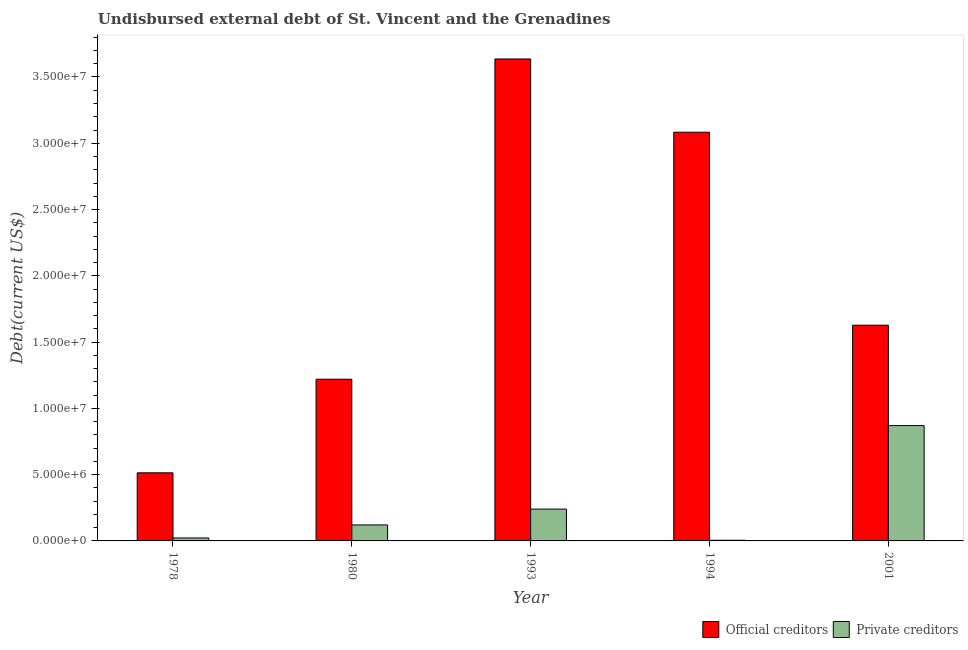How many groups of bars are there?
Keep it short and to the point. 5. How many bars are there on the 1st tick from the left?
Your answer should be compact. 2. What is the label of the 3rd group of bars from the left?
Offer a very short reply. 1993. In how many cases, is the number of bars for a given year not equal to the number of legend labels?
Ensure brevity in your answer.  0. What is the undisbursed external debt of private creditors in 1978?
Provide a succinct answer. 2.23e+05. Across all years, what is the maximum undisbursed external debt of official creditors?
Provide a succinct answer. 3.64e+07. Across all years, what is the minimum undisbursed external debt of official creditors?
Offer a very short reply. 5.14e+06. In which year was the undisbursed external debt of private creditors maximum?
Offer a very short reply. 2001. What is the total undisbursed external debt of private creditors in the graph?
Provide a succinct answer. 1.26e+07. What is the difference between the undisbursed external debt of official creditors in 1978 and that in 1993?
Offer a very short reply. -3.12e+07. What is the difference between the undisbursed external debt of official creditors in 1978 and the undisbursed external debt of private creditors in 2001?
Ensure brevity in your answer.  -1.11e+07. What is the average undisbursed external debt of official creditors per year?
Your answer should be compact. 2.02e+07. What is the ratio of the undisbursed external debt of private creditors in 1980 to that in 1993?
Provide a short and direct response. 0.5. Is the undisbursed external debt of official creditors in 1978 less than that in 1993?
Give a very brief answer. Yes. Is the difference between the undisbursed external debt of private creditors in 1993 and 2001 greater than the difference between the undisbursed external debt of official creditors in 1993 and 2001?
Ensure brevity in your answer.  No. What is the difference between the highest and the second highest undisbursed external debt of official creditors?
Offer a terse response. 5.52e+06. What is the difference between the highest and the lowest undisbursed external debt of private creditors?
Provide a succinct answer. 8.65e+06. Is the sum of the undisbursed external debt of official creditors in 1993 and 2001 greater than the maximum undisbursed external debt of private creditors across all years?
Offer a very short reply. Yes. What does the 1st bar from the left in 2001 represents?
Keep it short and to the point. Official creditors. What does the 2nd bar from the right in 1993 represents?
Provide a succinct answer. Official creditors. How many bars are there?
Offer a very short reply. 10. Are all the bars in the graph horizontal?
Make the answer very short. No. How many years are there in the graph?
Your answer should be compact. 5. Does the graph contain any zero values?
Keep it short and to the point. No. Where does the legend appear in the graph?
Provide a succinct answer. Bottom right. How many legend labels are there?
Offer a terse response. 2. What is the title of the graph?
Your answer should be very brief. Undisbursed external debt of St. Vincent and the Grenadines. Does "ODA received" appear as one of the legend labels in the graph?
Provide a short and direct response. No. What is the label or title of the X-axis?
Make the answer very short. Year. What is the label or title of the Y-axis?
Your answer should be very brief. Debt(current US$). What is the Debt(current US$) of Official creditors in 1978?
Provide a short and direct response. 5.14e+06. What is the Debt(current US$) in Private creditors in 1978?
Your response must be concise. 2.23e+05. What is the Debt(current US$) of Official creditors in 1980?
Your answer should be compact. 1.22e+07. What is the Debt(current US$) in Private creditors in 1980?
Ensure brevity in your answer.  1.21e+06. What is the Debt(current US$) in Official creditors in 1993?
Your answer should be very brief. 3.64e+07. What is the Debt(current US$) in Private creditors in 1993?
Offer a very short reply. 2.40e+06. What is the Debt(current US$) of Official creditors in 1994?
Offer a terse response. 3.08e+07. What is the Debt(current US$) in Private creditors in 1994?
Your response must be concise. 5.10e+04. What is the Debt(current US$) of Official creditors in 2001?
Your answer should be very brief. 1.63e+07. What is the Debt(current US$) in Private creditors in 2001?
Give a very brief answer. 8.70e+06. Across all years, what is the maximum Debt(current US$) in Official creditors?
Offer a very short reply. 3.64e+07. Across all years, what is the maximum Debt(current US$) of Private creditors?
Offer a very short reply. 8.70e+06. Across all years, what is the minimum Debt(current US$) in Official creditors?
Offer a very short reply. 5.14e+06. Across all years, what is the minimum Debt(current US$) of Private creditors?
Ensure brevity in your answer.  5.10e+04. What is the total Debt(current US$) of Official creditors in the graph?
Give a very brief answer. 1.01e+08. What is the total Debt(current US$) of Private creditors in the graph?
Ensure brevity in your answer.  1.26e+07. What is the difference between the Debt(current US$) of Official creditors in 1978 and that in 1980?
Ensure brevity in your answer.  -7.06e+06. What is the difference between the Debt(current US$) of Private creditors in 1978 and that in 1980?
Your answer should be compact. -9.84e+05. What is the difference between the Debt(current US$) of Official creditors in 1978 and that in 1993?
Provide a succinct answer. -3.12e+07. What is the difference between the Debt(current US$) in Private creditors in 1978 and that in 1993?
Offer a terse response. -2.18e+06. What is the difference between the Debt(current US$) of Official creditors in 1978 and that in 1994?
Your answer should be very brief. -2.57e+07. What is the difference between the Debt(current US$) in Private creditors in 1978 and that in 1994?
Keep it short and to the point. 1.72e+05. What is the difference between the Debt(current US$) of Official creditors in 1978 and that in 2001?
Give a very brief answer. -1.11e+07. What is the difference between the Debt(current US$) in Private creditors in 1978 and that in 2001?
Provide a short and direct response. -8.48e+06. What is the difference between the Debt(current US$) in Official creditors in 1980 and that in 1993?
Your response must be concise. -2.42e+07. What is the difference between the Debt(current US$) in Private creditors in 1980 and that in 1993?
Make the answer very short. -1.19e+06. What is the difference between the Debt(current US$) of Official creditors in 1980 and that in 1994?
Give a very brief answer. -1.86e+07. What is the difference between the Debt(current US$) of Private creditors in 1980 and that in 1994?
Provide a succinct answer. 1.16e+06. What is the difference between the Debt(current US$) of Official creditors in 1980 and that in 2001?
Your answer should be very brief. -4.08e+06. What is the difference between the Debt(current US$) of Private creditors in 1980 and that in 2001?
Provide a short and direct response. -7.49e+06. What is the difference between the Debt(current US$) of Official creditors in 1993 and that in 1994?
Your response must be concise. 5.52e+06. What is the difference between the Debt(current US$) in Private creditors in 1993 and that in 1994?
Ensure brevity in your answer.  2.35e+06. What is the difference between the Debt(current US$) of Official creditors in 1993 and that in 2001?
Your answer should be very brief. 2.01e+07. What is the difference between the Debt(current US$) of Private creditors in 1993 and that in 2001?
Give a very brief answer. -6.30e+06. What is the difference between the Debt(current US$) in Official creditors in 1994 and that in 2001?
Provide a short and direct response. 1.46e+07. What is the difference between the Debt(current US$) in Private creditors in 1994 and that in 2001?
Provide a short and direct response. -8.65e+06. What is the difference between the Debt(current US$) of Official creditors in 1978 and the Debt(current US$) of Private creditors in 1980?
Your answer should be compact. 3.93e+06. What is the difference between the Debt(current US$) in Official creditors in 1978 and the Debt(current US$) in Private creditors in 1993?
Give a very brief answer. 2.74e+06. What is the difference between the Debt(current US$) in Official creditors in 1978 and the Debt(current US$) in Private creditors in 1994?
Keep it short and to the point. 5.09e+06. What is the difference between the Debt(current US$) of Official creditors in 1978 and the Debt(current US$) of Private creditors in 2001?
Keep it short and to the point. -3.56e+06. What is the difference between the Debt(current US$) of Official creditors in 1980 and the Debt(current US$) of Private creditors in 1993?
Provide a short and direct response. 9.80e+06. What is the difference between the Debt(current US$) in Official creditors in 1980 and the Debt(current US$) in Private creditors in 1994?
Offer a very short reply. 1.21e+07. What is the difference between the Debt(current US$) in Official creditors in 1980 and the Debt(current US$) in Private creditors in 2001?
Your response must be concise. 3.50e+06. What is the difference between the Debt(current US$) in Official creditors in 1993 and the Debt(current US$) in Private creditors in 1994?
Ensure brevity in your answer.  3.63e+07. What is the difference between the Debt(current US$) in Official creditors in 1993 and the Debt(current US$) in Private creditors in 2001?
Provide a short and direct response. 2.77e+07. What is the difference between the Debt(current US$) of Official creditors in 1994 and the Debt(current US$) of Private creditors in 2001?
Offer a terse response. 2.21e+07. What is the average Debt(current US$) in Official creditors per year?
Your answer should be compact. 2.02e+07. What is the average Debt(current US$) of Private creditors per year?
Provide a succinct answer. 2.52e+06. In the year 1978, what is the difference between the Debt(current US$) in Official creditors and Debt(current US$) in Private creditors?
Keep it short and to the point. 4.92e+06. In the year 1980, what is the difference between the Debt(current US$) in Official creditors and Debt(current US$) in Private creditors?
Provide a short and direct response. 1.10e+07. In the year 1993, what is the difference between the Debt(current US$) of Official creditors and Debt(current US$) of Private creditors?
Offer a terse response. 3.40e+07. In the year 1994, what is the difference between the Debt(current US$) in Official creditors and Debt(current US$) in Private creditors?
Ensure brevity in your answer.  3.08e+07. In the year 2001, what is the difference between the Debt(current US$) of Official creditors and Debt(current US$) of Private creditors?
Make the answer very short. 7.58e+06. What is the ratio of the Debt(current US$) of Official creditors in 1978 to that in 1980?
Ensure brevity in your answer.  0.42. What is the ratio of the Debt(current US$) in Private creditors in 1978 to that in 1980?
Make the answer very short. 0.18. What is the ratio of the Debt(current US$) of Official creditors in 1978 to that in 1993?
Ensure brevity in your answer.  0.14. What is the ratio of the Debt(current US$) in Private creditors in 1978 to that in 1993?
Make the answer very short. 0.09. What is the ratio of the Debt(current US$) of Official creditors in 1978 to that in 1994?
Your answer should be compact. 0.17. What is the ratio of the Debt(current US$) of Private creditors in 1978 to that in 1994?
Your response must be concise. 4.37. What is the ratio of the Debt(current US$) of Official creditors in 1978 to that in 2001?
Give a very brief answer. 0.32. What is the ratio of the Debt(current US$) of Private creditors in 1978 to that in 2001?
Your answer should be compact. 0.03. What is the ratio of the Debt(current US$) in Official creditors in 1980 to that in 1993?
Your response must be concise. 0.34. What is the ratio of the Debt(current US$) in Private creditors in 1980 to that in 1993?
Ensure brevity in your answer.  0.5. What is the ratio of the Debt(current US$) of Official creditors in 1980 to that in 1994?
Offer a very short reply. 0.4. What is the ratio of the Debt(current US$) of Private creditors in 1980 to that in 1994?
Provide a short and direct response. 23.67. What is the ratio of the Debt(current US$) of Official creditors in 1980 to that in 2001?
Keep it short and to the point. 0.75. What is the ratio of the Debt(current US$) of Private creditors in 1980 to that in 2001?
Provide a short and direct response. 0.14. What is the ratio of the Debt(current US$) in Official creditors in 1993 to that in 1994?
Ensure brevity in your answer.  1.18. What is the ratio of the Debt(current US$) in Private creditors in 1993 to that in 1994?
Your answer should be compact. 47.06. What is the ratio of the Debt(current US$) of Official creditors in 1993 to that in 2001?
Offer a very short reply. 2.23. What is the ratio of the Debt(current US$) of Private creditors in 1993 to that in 2001?
Give a very brief answer. 0.28. What is the ratio of the Debt(current US$) of Official creditors in 1994 to that in 2001?
Your response must be concise. 1.89. What is the ratio of the Debt(current US$) in Private creditors in 1994 to that in 2001?
Keep it short and to the point. 0.01. What is the difference between the highest and the second highest Debt(current US$) of Official creditors?
Ensure brevity in your answer.  5.52e+06. What is the difference between the highest and the second highest Debt(current US$) of Private creditors?
Your answer should be very brief. 6.30e+06. What is the difference between the highest and the lowest Debt(current US$) of Official creditors?
Offer a terse response. 3.12e+07. What is the difference between the highest and the lowest Debt(current US$) in Private creditors?
Your answer should be very brief. 8.65e+06. 